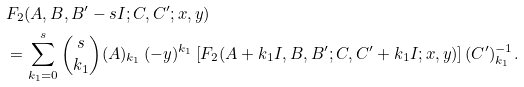<formula> <loc_0><loc_0><loc_500><loc_500>& F _ { 2 } ( A , B , B ^ { \prime } - s I ; C , C ^ { \prime } ; x , y ) \\ & = \sum _ { k _ { 1 } = 0 } ^ { s } { s \choose k _ { 1 } } { ( A ) _ { k _ { 1 } } } \, ( - y ) ^ { k _ { 1 } } \left [ { F _ { 2 } } ( A + k _ { 1 } I , B , B ^ { \prime } ; C , C ^ { \prime } + k _ { 1 } I ; x , y ) \right ] { ( C ^ { \prime } ) ^ { - 1 } _ { k _ { 1 } } } .</formula> 